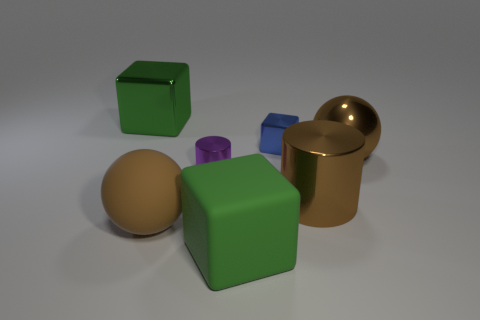Subtract all big shiny blocks. How many blocks are left? 2 Subtract all yellow balls. How many green blocks are left? 2 Add 3 green cubes. How many objects exist? 10 Subtract all balls. How many objects are left? 5 Subtract all yellow blocks. Subtract all purple cylinders. How many blocks are left? 3 Subtract all big cubes. Subtract all small metallic blocks. How many objects are left? 4 Add 3 big rubber balls. How many big rubber balls are left? 4 Add 4 large metal cylinders. How many large metal cylinders exist? 5 Subtract 2 green cubes. How many objects are left? 5 